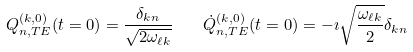Convert formula to latex. <formula><loc_0><loc_0><loc_500><loc_500>\ Q ^ { ( k , 0 ) } _ { n , T E } ( t = 0 ) = \frac { \delta _ { k n } } { \sqrt { 2 \omega _ { \ell k } } } \quad \dot { Q } ^ { ( k , 0 ) } _ { n , T E } ( t = 0 ) = - \imath \sqrt { \frac { \omega _ { \ell k } } { 2 } } \delta _ { k n }</formula> 